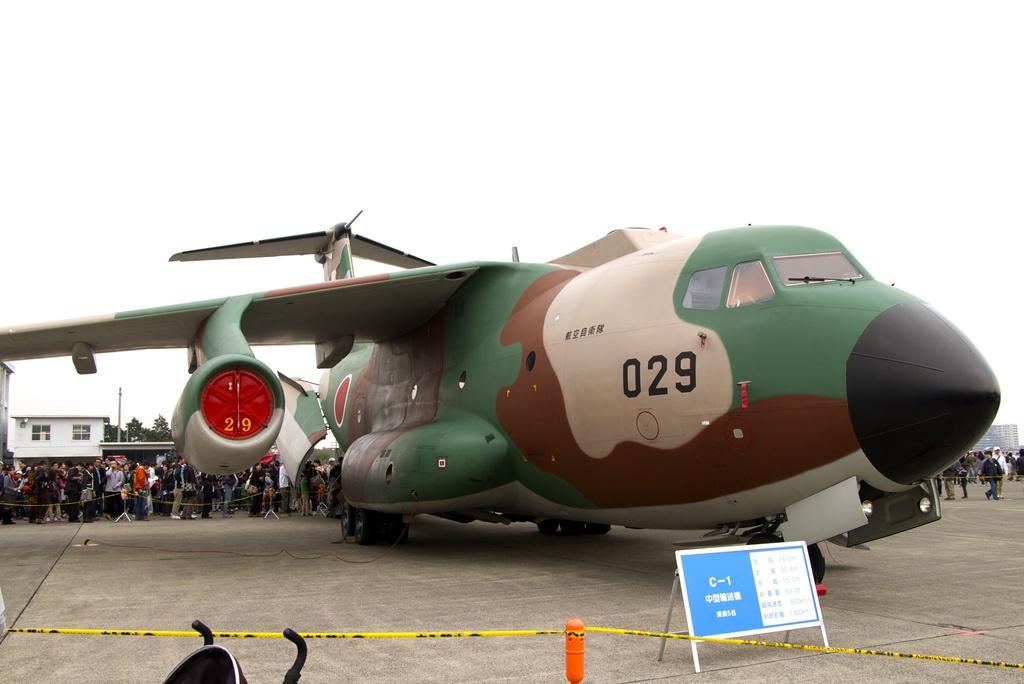<image>
Provide a brief description of the given image. A large military plane with the number 029 on the fuselage. 